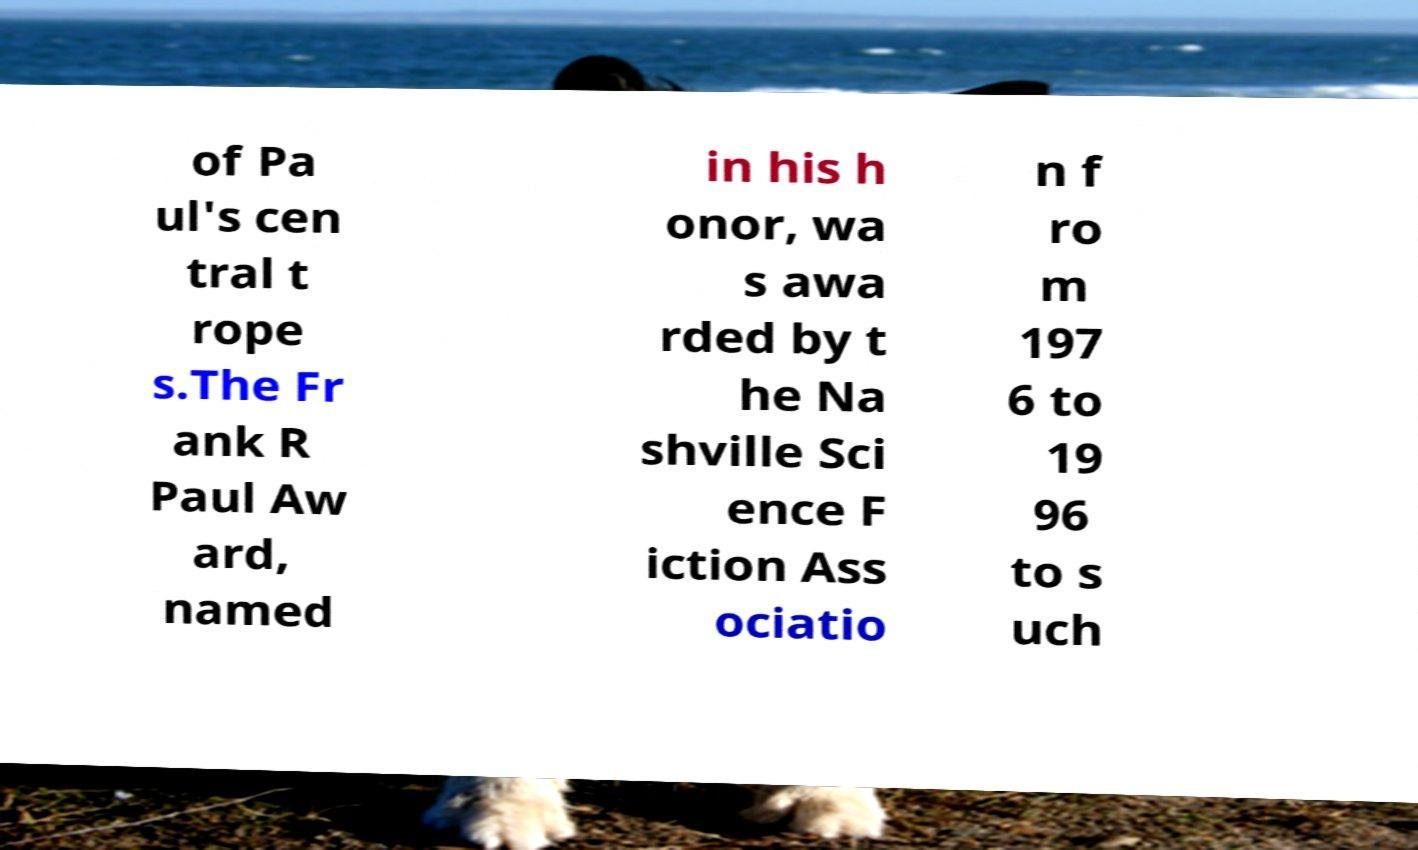Could you extract and type out the text from this image? of Pa ul's cen tral t rope s.The Fr ank R Paul Aw ard, named in his h onor, wa s awa rded by t he Na shville Sci ence F iction Ass ociatio n f ro m 197 6 to 19 96 to s uch 